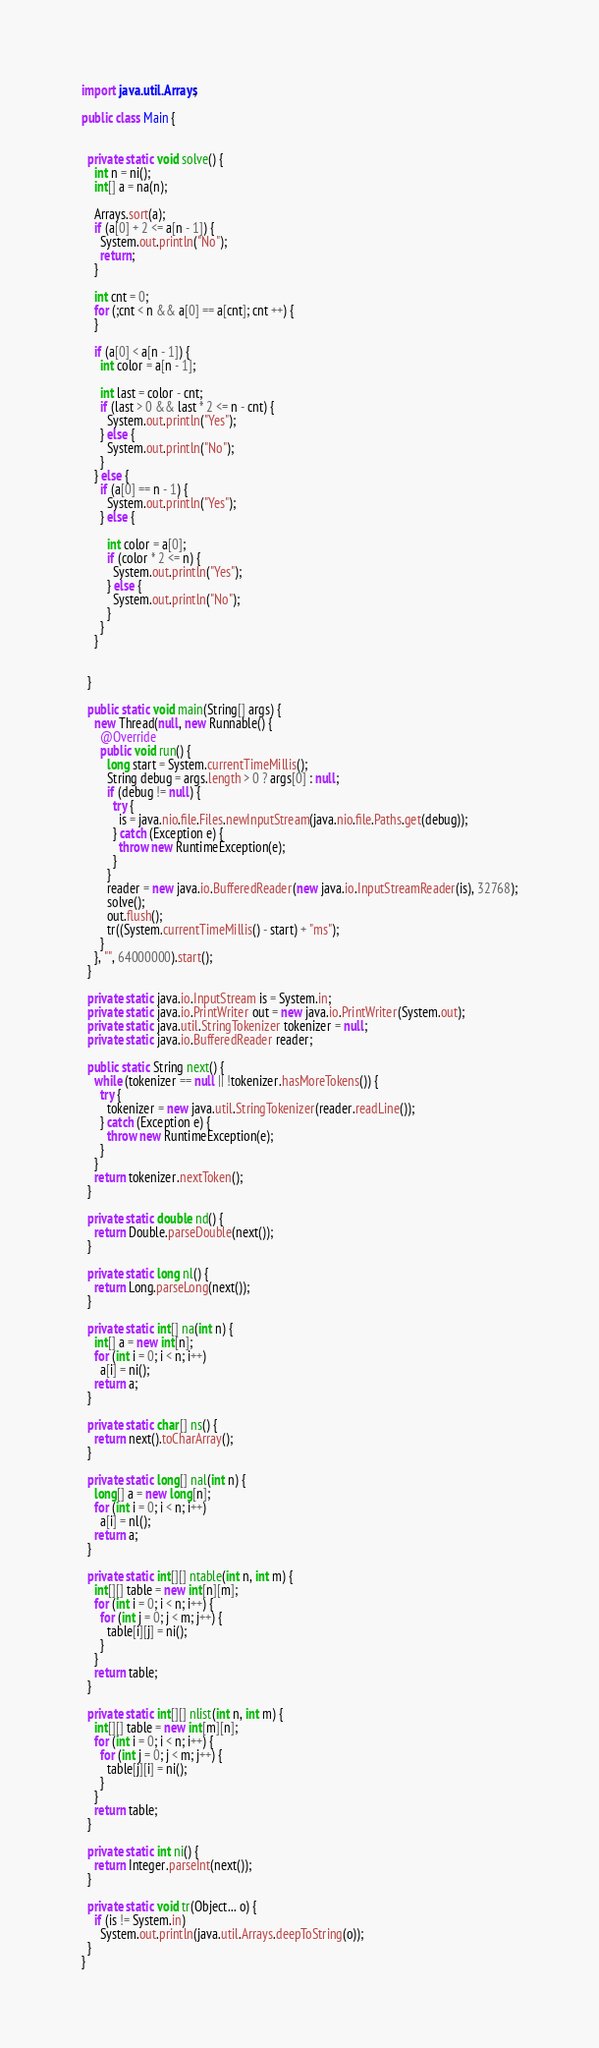Convert code to text. <code><loc_0><loc_0><loc_500><loc_500><_Java_>
import java.util.Arrays;

public class Main {


  private static void solve() {
    int n = ni();
    int[] a = na(n);
    
    Arrays.sort(a);
    if (a[0] + 2 <= a[n - 1]) {
      System.out.println("No");
      return;
    }
    
    int cnt = 0;
    for (;cnt < n && a[0] == a[cnt]; cnt ++) {
    }
    
    if (a[0] < a[n - 1]) {
      int color = a[n - 1];
      
      int last = color - cnt;
      if (last > 0 && last * 2 <= n - cnt) {
        System.out.println("Yes");
      } else {
        System.out.println("No");
      }
    } else {
      if (a[0] == n - 1) {
        System.out.println("Yes");
      } else {
        
        int color = a[0];
        if (color * 2 <= n) {
          System.out.println("Yes");
        } else {
          System.out.println("No");
        }
      }
    }
    
   
  }

  public static void main(String[] args) {
    new Thread(null, new Runnable() {
      @Override
      public void run() {
        long start = System.currentTimeMillis();
        String debug = args.length > 0 ? args[0] : null;
        if (debug != null) {
          try {
            is = java.nio.file.Files.newInputStream(java.nio.file.Paths.get(debug));
          } catch (Exception e) {
            throw new RuntimeException(e);
          }
        }
        reader = new java.io.BufferedReader(new java.io.InputStreamReader(is), 32768);
        solve();
        out.flush();
        tr((System.currentTimeMillis() - start) + "ms");
      }
    }, "", 64000000).start();
  }

  private static java.io.InputStream is = System.in;
  private static java.io.PrintWriter out = new java.io.PrintWriter(System.out);
  private static java.util.StringTokenizer tokenizer = null;
  private static java.io.BufferedReader reader;

  public static String next() {
    while (tokenizer == null || !tokenizer.hasMoreTokens()) {
      try {
        tokenizer = new java.util.StringTokenizer(reader.readLine());
      } catch (Exception e) {
        throw new RuntimeException(e);
      }
    }
    return tokenizer.nextToken();
  }

  private static double nd() {
    return Double.parseDouble(next());
  }

  private static long nl() {
    return Long.parseLong(next());
  }

  private static int[] na(int n) {
    int[] a = new int[n];
    for (int i = 0; i < n; i++)
      a[i] = ni();
    return a;
  }

  private static char[] ns() {
    return next().toCharArray();
  }

  private static long[] nal(int n) {
    long[] a = new long[n];
    for (int i = 0; i < n; i++)
      a[i] = nl();
    return a;
  }

  private static int[][] ntable(int n, int m) {
    int[][] table = new int[n][m];
    for (int i = 0; i < n; i++) {
      for (int j = 0; j < m; j++) {
        table[i][j] = ni();
      }
    }
    return table;
  }

  private static int[][] nlist(int n, int m) {
    int[][] table = new int[m][n];
    for (int i = 0; i < n; i++) {
      for (int j = 0; j < m; j++) {
        table[j][i] = ni();
      }
    }
    return table;
  }

  private static int ni() {
    return Integer.parseInt(next());
  }

  private static void tr(Object... o) {
    if (is != System.in)
      System.out.println(java.util.Arrays.deepToString(o));
  }
}
</code> 